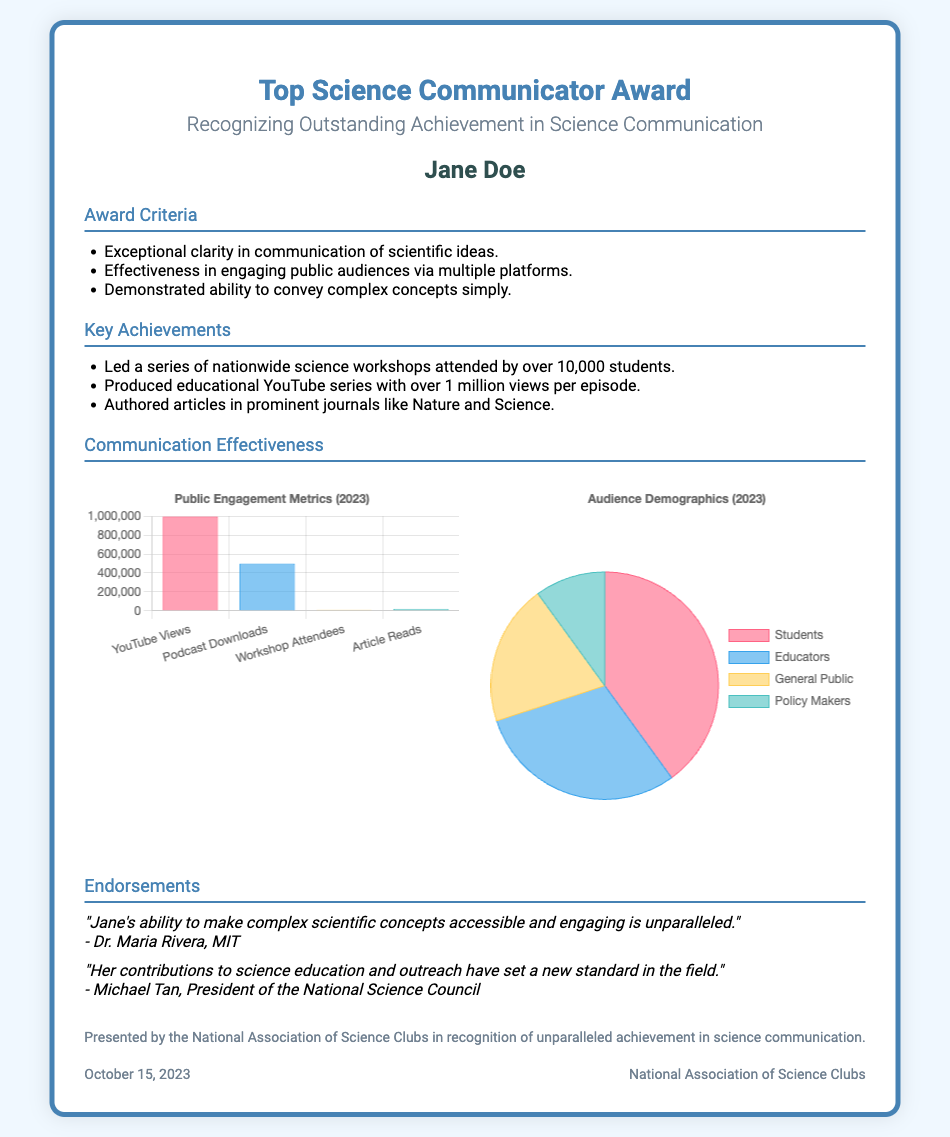what is the name of the award? The award is explicitly named at the top of the document.
Answer: Top Science Communicator Award who is the recipient of the award? The recipient's name is mentioned in a specific section.
Answer: Jane Doe how many students attended the workshops led by Jane Doe? The number of students is specified in the achievements section.
Answer: over 10,000 students what is the total number of YouTube views per episode mentioned? The number of views is given in the Key Achievements section.
Answer: over 1 million views per episode who endorsed Jane Doe's communication skills? The names of individuals providing endorsements are clearly listed.
Answer: Dr. Maria Rivera and Michael Tan how many audience segments are represented in the pie chart? The pie chart displays specific demographic groups.
Answer: 4 what is the highest public engagement metric in the bar chart? The bar chart lists specific engagement metrics with their values.
Answer: 1,000,000 when was the award presented? The date of the award presentation is mentioned in the footer.
Answer: October 15, 2023 what organization presented the award? The presenting organization is stated in the footer section.
Answer: National Association of Science Clubs 